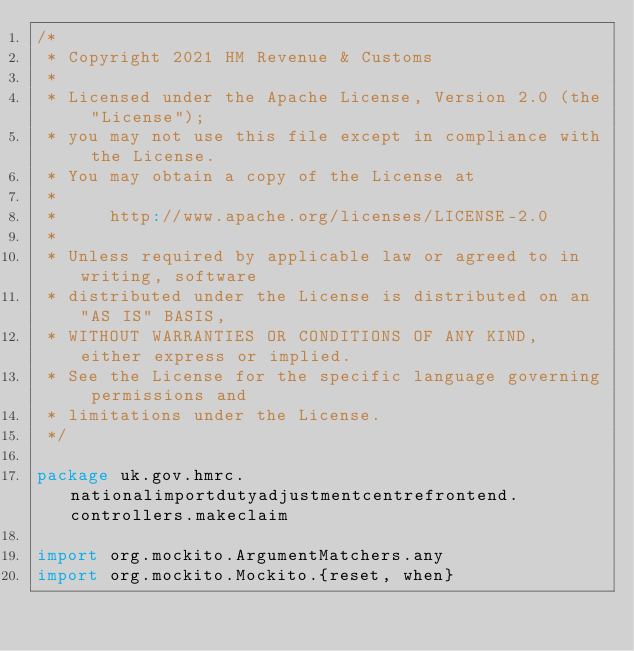Convert code to text. <code><loc_0><loc_0><loc_500><loc_500><_Scala_>/*
 * Copyright 2021 HM Revenue & Customs
 *
 * Licensed under the Apache License, Version 2.0 (the "License");
 * you may not use this file except in compliance with the License.
 * You may obtain a copy of the License at
 *
 *     http://www.apache.org/licenses/LICENSE-2.0
 *
 * Unless required by applicable law or agreed to in writing, software
 * distributed under the License is distributed on an "AS IS" BASIS,
 * WITHOUT WARRANTIES OR CONDITIONS OF ANY KIND, either express or implied.
 * See the License for the specific language governing permissions and
 * limitations under the License.
 */

package uk.gov.hmrc.nationalimportdutyadjustmentcentrefrontend.controllers.makeclaim

import org.mockito.ArgumentMatchers.any
import org.mockito.Mockito.{reset, when}</code> 